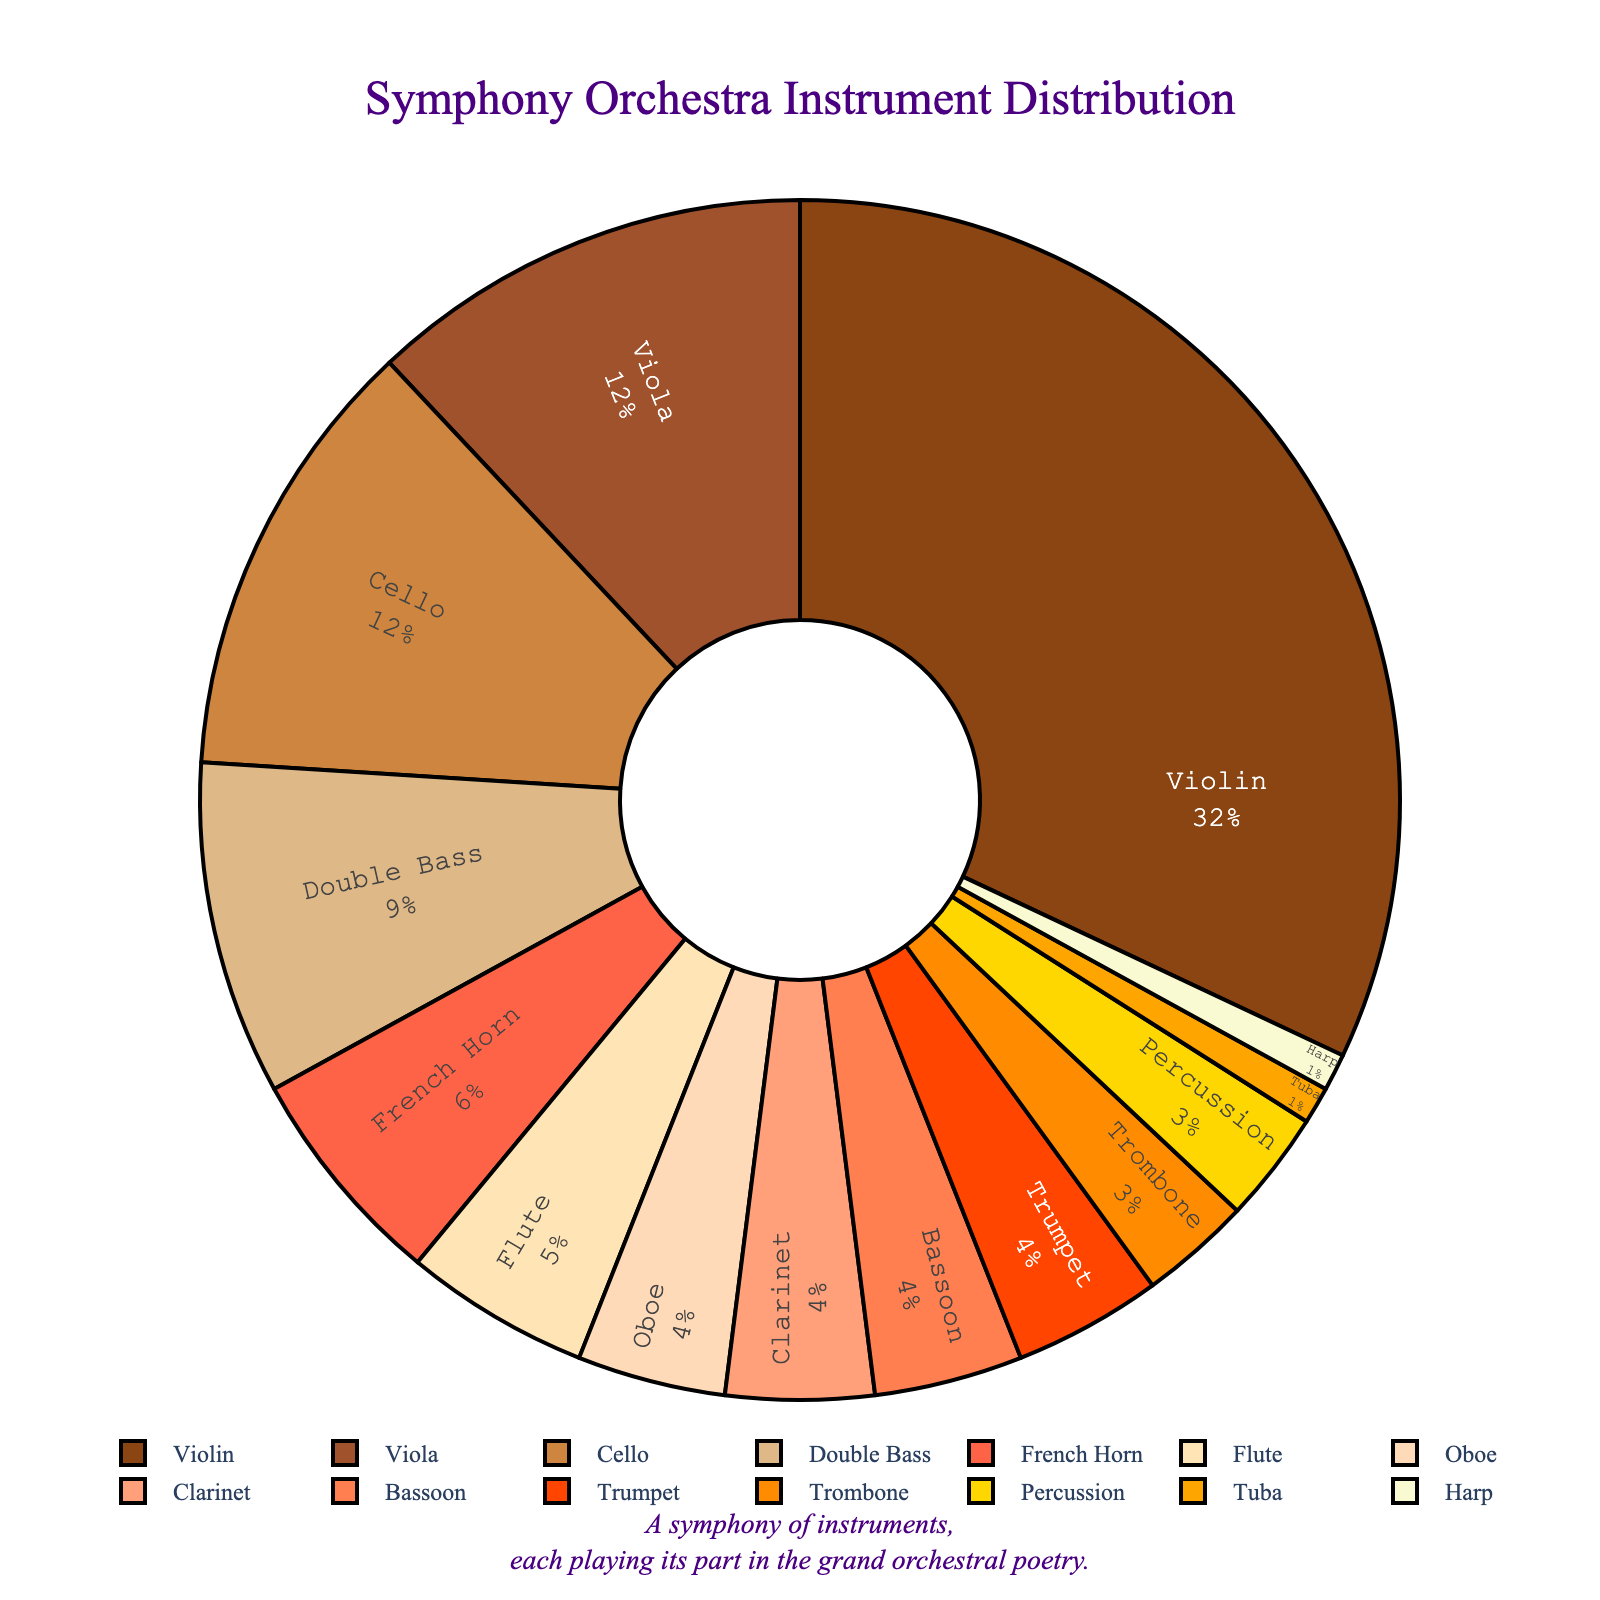What's the most represented instrument in the symphony orchestra based on the figure? By observing the pie chart, the instrument with the largest section corresponds to 32%, which is the Violin.
Answer: Violin Which instruments have an equal representation in the orchestra? Looking at the pie chart, we can see that Cello and Viola both have a percentage of 12%. Additionally, Oboe, Clarinet, Bassoon, and Trumpet each have 4%.
Answer: Cello and Viola; Oboe, Clarinet, Bassoon, and Trumpet What is the total percentage of string instruments (Violin, Viola, Cello, Double Bass, and Harp) in the orchestra? Sum the percentages of Violin (32%), Viola (12%), Cello (12%), Double Bass (9%), and Harp (1%). 32 + 12 + 12 + 9 + 1 = 66.
Answer: 66% How does the proportion of Flutes compare to that of Trombones in the orchestra? The pie chart shows Flutes at 5% and Trombones at 3%. Therefore, Flutes are greater than Trombones by 2%.
Answer: Flutes are 2% more than Trombones Between percussion and harp, which is more and by how much? As indicated in the chart, Percussion has 3% while Harp has 1%, so Percussion is more by 2%.
Answer: Percussion, by 2% What percentage of the orchestra is made up of wind instruments (Flute, Oboe, Clarinet, Bassoon, and French Horn)? Adding the percentages: Flute (5%), Oboe (4%), Clarinet (4%), Bassoon (4%), and French Horn (6%). 5 + 4 + 4 + 4 + 6 = 23.
Answer: 23% What is the combined percentage of brass instruments (French Horn, Trumpet, Trombone, and Tuba)? Sum the percentages: French Horn (6%), Trumpet (4%), Trombone (3%), and Tuba (1%). 6 + 4 + 3 + 1 = 14.
Answer: 14% What is the difference in representation between the most abundant and the least abundant instrument? The most abundant instrument is Violin at 32% and the least abundant is Tuba and Harp at 1%. 32 - 1 = 31%.
Answer: 31% Among Oboe, Clarinet, and Bassoon, which instrument has the highest representation? All three instruments show 4% representation each, so they all have equal representation.
Answer: Oboe, Clarinet, and Bassoon have equal representation 